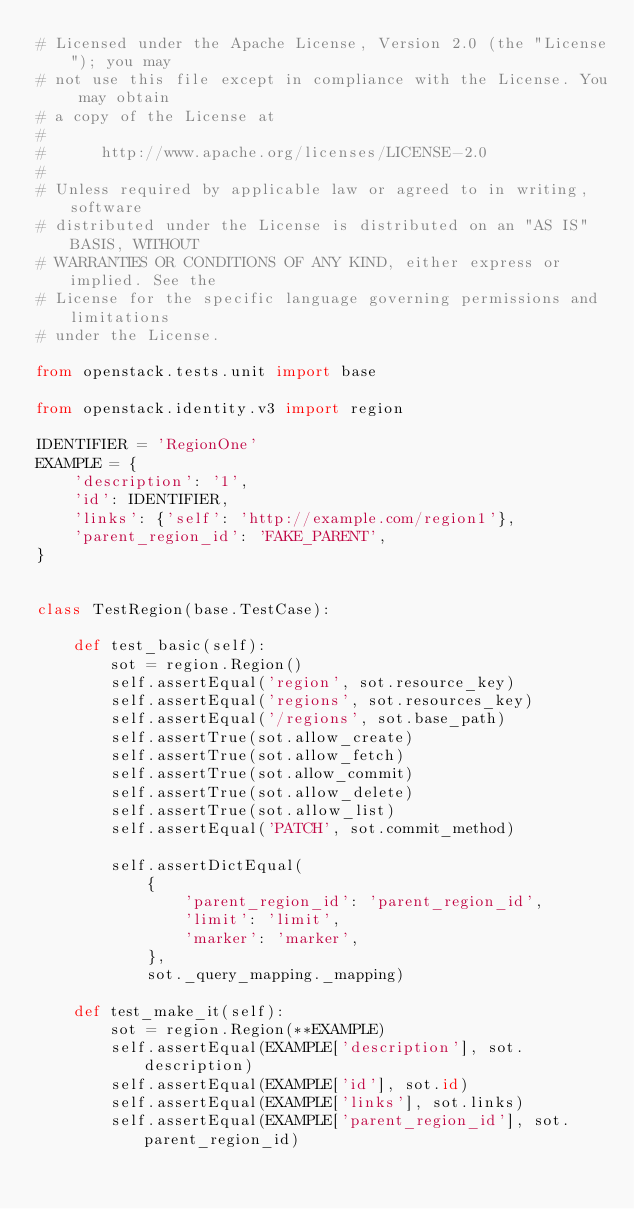Convert code to text. <code><loc_0><loc_0><loc_500><loc_500><_Python_># Licensed under the Apache License, Version 2.0 (the "License"); you may
# not use this file except in compliance with the License. You may obtain
# a copy of the License at
#
#      http://www.apache.org/licenses/LICENSE-2.0
#
# Unless required by applicable law or agreed to in writing, software
# distributed under the License is distributed on an "AS IS" BASIS, WITHOUT
# WARRANTIES OR CONDITIONS OF ANY KIND, either express or implied. See the
# License for the specific language governing permissions and limitations
# under the License.

from openstack.tests.unit import base

from openstack.identity.v3 import region

IDENTIFIER = 'RegionOne'
EXAMPLE = {
    'description': '1',
    'id': IDENTIFIER,
    'links': {'self': 'http://example.com/region1'},
    'parent_region_id': 'FAKE_PARENT',
}


class TestRegion(base.TestCase):

    def test_basic(self):
        sot = region.Region()
        self.assertEqual('region', sot.resource_key)
        self.assertEqual('regions', sot.resources_key)
        self.assertEqual('/regions', sot.base_path)
        self.assertTrue(sot.allow_create)
        self.assertTrue(sot.allow_fetch)
        self.assertTrue(sot.allow_commit)
        self.assertTrue(sot.allow_delete)
        self.assertTrue(sot.allow_list)
        self.assertEqual('PATCH', sot.commit_method)

        self.assertDictEqual(
            {
                'parent_region_id': 'parent_region_id',
                'limit': 'limit',
                'marker': 'marker',
            },
            sot._query_mapping._mapping)

    def test_make_it(self):
        sot = region.Region(**EXAMPLE)
        self.assertEqual(EXAMPLE['description'], sot.description)
        self.assertEqual(EXAMPLE['id'], sot.id)
        self.assertEqual(EXAMPLE['links'], sot.links)
        self.assertEqual(EXAMPLE['parent_region_id'], sot.parent_region_id)
</code> 